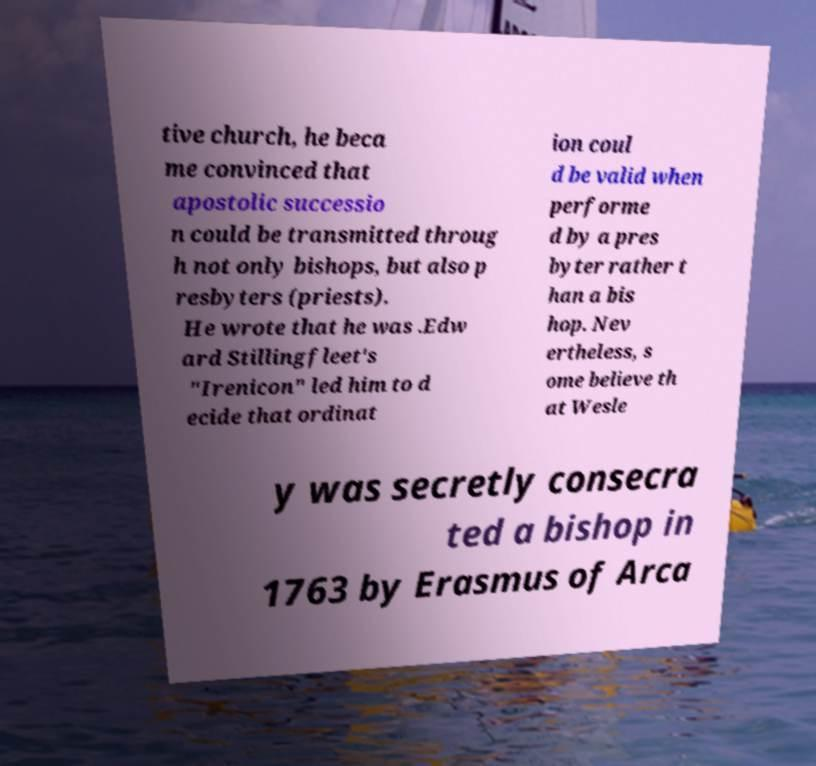I need the written content from this picture converted into text. Can you do that? tive church, he beca me convinced that apostolic successio n could be transmitted throug h not only bishops, but also p resbyters (priests). He wrote that he was .Edw ard Stillingfleet's "Irenicon" led him to d ecide that ordinat ion coul d be valid when performe d by a pres byter rather t han a bis hop. Nev ertheless, s ome believe th at Wesle y was secretly consecra ted a bishop in 1763 by Erasmus of Arca 